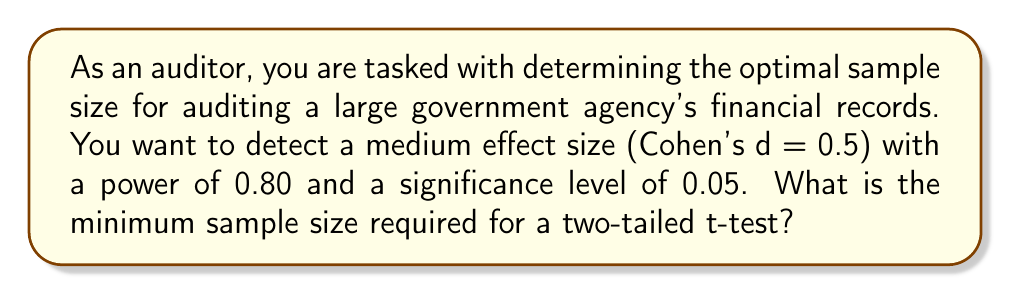Give your solution to this math problem. To determine the optimal sample size for auditing using power analysis, we'll follow these steps:

1. Define the parameters:
   - Effect size (Cohen's d) = 0.5 (medium effect)
   - Desired power = 0.80
   - Significance level (α) = 0.05
   - Two-tailed test

2. Use the power analysis formula for a two-tailed t-test:

   $$n = \frac{2(z_{1-\alpha/2} + z_{1-\beta})^2}{d^2}$$

   Where:
   - $n$ is the sample size
   - $z_{1-\alpha/2}$ is the critical value for the significance level
   - $z_{1-\beta}$ is the critical value for the desired power
   - $d$ is Cohen's d (effect size)

3. Find the critical values:
   - For α = 0.05 (two-tailed), $z_{1-\alpha/2} = z_{0.975} = 1.96$
   - For power = 0.80, $z_{1-\beta} = z_{0.80} = 0.84$

4. Plug the values into the formula:

   $$n = \frac{2(1.96 + 0.84)^2}{0.5^2}$$

5. Solve the equation:

   $$n = \frac{2(2.80)^2}{0.25} = \frac{2(7.84)}{0.25} = \frac{15.68}{0.25} = 62.72$$

6. Round up to the nearest whole number, as we can't have a fractional sample size.

Therefore, the minimum sample size required is 63.
Answer: 63 